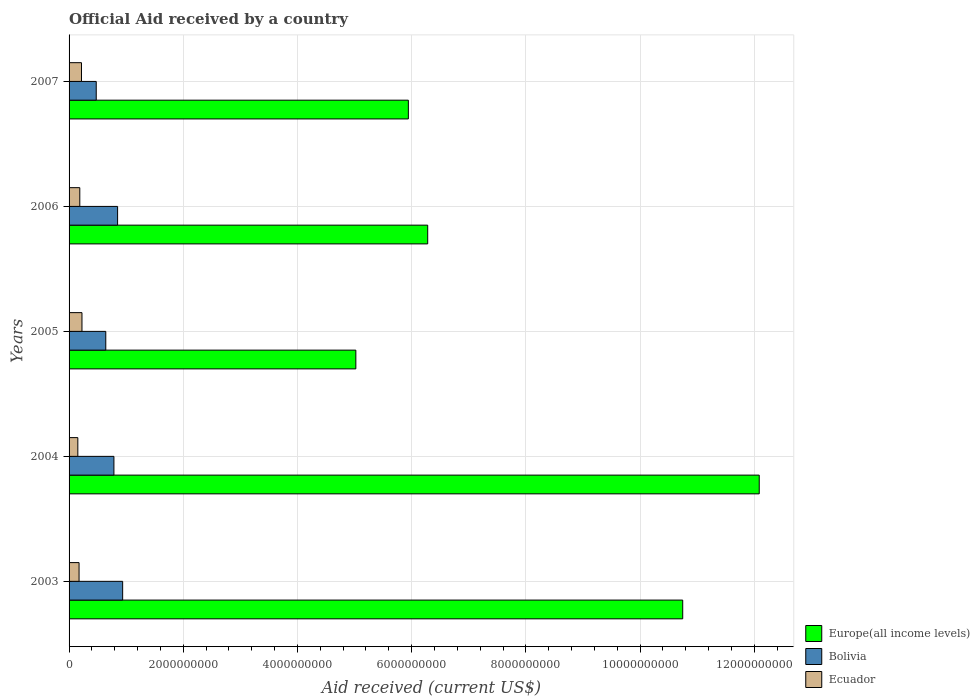How many different coloured bars are there?
Ensure brevity in your answer.  3. What is the net official aid received in Ecuador in 2004?
Offer a very short reply. 1.53e+08. Across all years, what is the maximum net official aid received in Ecuador?
Offer a terse response. 2.26e+08. Across all years, what is the minimum net official aid received in Ecuador?
Keep it short and to the point. 1.53e+08. In which year was the net official aid received in Ecuador maximum?
Your response must be concise. 2005. In which year was the net official aid received in Europe(all income levels) minimum?
Give a very brief answer. 2005. What is the total net official aid received in Bolivia in the graph?
Your answer should be very brief. 3.69e+09. What is the difference between the net official aid received in Europe(all income levels) in 2003 and that in 2004?
Offer a very short reply. -1.34e+09. What is the difference between the net official aid received in Europe(all income levels) in 2004 and the net official aid received in Ecuador in 2003?
Your response must be concise. 1.19e+1. What is the average net official aid received in Bolivia per year?
Your response must be concise. 7.39e+08. In the year 2007, what is the difference between the net official aid received in Europe(all income levels) and net official aid received in Ecuador?
Your response must be concise. 5.73e+09. What is the ratio of the net official aid received in Bolivia in 2003 to that in 2005?
Ensure brevity in your answer.  1.46. What is the difference between the highest and the second highest net official aid received in Europe(all income levels)?
Your response must be concise. 1.34e+09. What is the difference between the highest and the lowest net official aid received in Bolivia?
Your answer should be compact. 4.63e+08. What does the 1st bar from the bottom in 2005 represents?
Your answer should be compact. Europe(all income levels). How many bars are there?
Give a very brief answer. 15. How many years are there in the graph?
Make the answer very short. 5. What is the difference between two consecutive major ticks on the X-axis?
Give a very brief answer. 2.00e+09. Does the graph contain grids?
Provide a succinct answer. Yes. What is the title of the graph?
Your answer should be very brief. Official Aid received by a country. What is the label or title of the X-axis?
Keep it short and to the point. Aid received (current US$). What is the label or title of the Y-axis?
Provide a succinct answer. Years. What is the Aid received (current US$) of Europe(all income levels) in 2003?
Provide a succinct answer. 1.07e+1. What is the Aid received (current US$) of Bolivia in 2003?
Provide a succinct answer. 9.38e+08. What is the Aid received (current US$) in Ecuador in 2003?
Offer a terse response. 1.75e+08. What is the Aid received (current US$) of Europe(all income levels) in 2004?
Keep it short and to the point. 1.21e+1. What is the Aid received (current US$) of Bolivia in 2004?
Offer a terse response. 7.85e+08. What is the Aid received (current US$) in Ecuador in 2004?
Ensure brevity in your answer.  1.53e+08. What is the Aid received (current US$) in Europe(all income levels) in 2005?
Make the answer very short. 5.02e+09. What is the Aid received (current US$) of Bolivia in 2005?
Provide a short and direct response. 6.43e+08. What is the Aid received (current US$) of Ecuador in 2005?
Your answer should be compact. 2.26e+08. What is the Aid received (current US$) of Europe(all income levels) in 2006?
Your answer should be very brief. 6.28e+09. What is the Aid received (current US$) in Bolivia in 2006?
Offer a terse response. 8.50e+08. What is the Aid received (current US$) in Ecuador in 2006?
Give a very brief answer. 1.88e+08. What is the Aid received (current US$) in Europe(all income levels) in 2007?
Give a very brief answer. 5.94e+09. What is the Aid received (current US$) in Bolivia in 2007?
Give a very brief answer. 4.76e+08. What is the Aid received (current US$) of Ecuador in 2007?
Give a very brief answer. 2.17e+08. Across all years, what is the maximum Aid received (current US$) of Europe(all income levels)?
Provide a short and direct response. 1.21e+1. Across all years, what is the maximum Aid received (current US$) of Bolivia?
Your answer should be compact. 9.38e+08. Across all years, what is the maximum Aid received (current US$) in Ecuador?
Give a very brief answer. 2.26e+08. Across all years, what is the minimum Aid received (current US$) in Europe(all income levels)?
Offer a very short reply. 5.02e+09. Across all years, what is the minimum Aid received (current US$) in Bolivia?
Your answer should be compact. 4.76e+08. Across all years, what is the minimum Aid received (current US$) of Ecuador?
Your answer should be compact. 1.53e+08. What is the total Aid received (current US$) of Europe(all income levels) in the graph?
Offer a very short reply. 4.01e+1. What is the total Aid received (current US$) in Bolivia in the graph?
Provide a short and direct response. 3.69e+09. What is the total Aid received (current US$) in Ecuador in the graph?
Provide a succinct answer. 9.59e+08. What is the difference between the Aid received (current US$) in Europe(all income levels) in 2003 and that in 2004?
Offer a terse response. -1.34e+09. What is the difference between the Aid received (current US$) of Bolivia in 2003 and that in 2004?
Your response must be concise. 1.53e+08. What is the difference between the Aid received (current US$) of Ecuador in 2003 and that in 2004?
Provide a succinct answer. 2.16e+07. What is the difference between the Aid received (current US$) in Europe(all income levels) in 2003 and that in 2005?
Your answer should be compact. 5.72e+09. What is the difference between the Aid received (current US$) of Bolivia in 2003 and that in 2005?
Provide a short and direct response. 2.95e+08. What is the difference between the Aid received (current US$) in Ecuador in 2003 and that in 2005?
Offer a terse response. -5.09e+07. What is the difference between the Aid received (current US$) in Europe(all income levels) in 2003 and that in 2006?
Provide a succinct answer. 4.47e+09. What is the difference between the Aid received (current US$) of Bolivia in 2003 and that in 2006?
Ensure brevity in your answer.  8.84e+07. What is the difference between the Aid received (current US$) of Ecuador in 2003 and that in 2006?
Your response must be concise. -1.28e+07. What is the difference between the Aid received (current US$) of Europe(all income levels) in 2003 and that in 2007?
Offer a terse response. 4.81e+09. What is the difference between the Aid received (current US$) in Bolivia in 2003 and that in 2007?
Ensure brevity in your answer.  4.63e+08. What is the difference between the Aid received (current US$) in Ecuador in 2003 and that in 2007?
Ensure brevity in your answer.  -4.24e+07. What is the difference between the Aid received (current US$) in Europe(all income levels) in 2004 and that in 2005?
Offer a very short reply. 7.07e+09. What is the difference between the Aid received (current US$) of Bolivia in 2004 and that in 2005?
Your answer should be very brief. 1.42e+08. What is the difference between the Aid received (current US$) of Ecuador in 2004 and that in 2005?
Ensure brevity in your answer.  -7.25e+07. What is the difference between the Aid received (current US$) of Europe(all income levels) in 2004 and that in 2006?
Give a very brief answer. 5.81e+09. What is the difference between the Aid received (current US$) in Bolivia in 2004 and that in 2006?
Ensure brevity in your answer.  -6.45e+07. What is the difference between the Aid received (current US$) of Ecuador in 2004 and that in 2006?
Your response must be concise. -3.45e+07. What is the difference between the Aid received (current US$) of Europe(all income levels) in 2004 and that in 2007?
Keep it short and to the point. 6.15e+09. What is the difference between the Aid received (current US$) in Bolivia in 2004 and that in 2007?
Offer a very short reply. 3.10e+08. What is the difference between the Aid received (current US$) in Ecuador in 2004 and that in 2007?
Keep it short and to the point. -6.40e+07. What is the difference between the Aid received (current US$) in Europe(all income levels) in 2005 and that in 2006?
Your response must be concise. -1.26e+09. What is the difference between the Aid received (current US$) in Bolivia in 2005 and that in 2006?
Your answer should be compact. -2.07e+08. What is the difference between the Aid received (current US$) of Ecuador in 2005 and that in 2006?
Provide a succinct answer. 3.80e+07. What is the difference between the Aid received (current US$) of Europe(all income levels) in 2005 and that in 2007?
Ensure brevity in your answer.  -9.20e+08. What is the difference between the Aid received (current US$) in Bolivia in 2005 and that in 2007?
Provide a succinct answer. 1.67e+08. What is the difference between the Aid received (current US$) of Ecuador in 2005 and that in 2007?
Keep it short and to the point. 8.52e+06. What is the difference between the Aid received (current US$) of Europe(all income levels) in 2006 and that in 2007?
Your response must be concise. 3.39e+08. What is the difference between the Aid received (current US$) of Bolivia in 2006 and that in 2007?
Offer a very short reply. 3.74e+08. What is the difference between the Aid received (current US$) of Ecuador in 2006 and that in 2007?
Make the answer very short. -2.95e+07. What is the difference between the Aid received (current US$) in Europe(all income levels) in 2003 and the Aid received (current US$) in Bolivia in 2004?
Offer a very short reply. 9.96e+09. What is the difference between the Aid received (current US$) in Europe(all income levels) in 2003 and the Aid received (current US$) in Ecuador in 2004?
Ensure brevity in your answer.  1.06e+1. What is the difference between the Aid received (current US$) of Bolivia in 2003 and the Aid received (current US$) of Ecuador in 2004?
Provide a short and direct response. 7.85e+08. What is the difference between the Aid received (current US$) of Europe(all income levels) in 2003 and the Aid received (current US$) of Bolivia in 2005?
Your answer should be compact. 1.01e+1. What is the difference between the Aid received (current US$) of Europe(all income levels) in 2003 and the Aid received (current US$) of Ecuador in 2005?
Make the answer very short. 1.05e+1. What is the difference between the Aid received (current US$) in Bolivia in 2003 and the Aid received (current US$) in Ecuador in 2005?
Give a very brief answer. 7.13e+08. What is the difference between the Aid received (current US$) in Europe(all income levels) in 2003 and the Aid received (current US$) in Bolivia in 2006?
Make the answer very short. 9.90e+09. What is the difference between the Aid received (current US$) of Europe(all income levels) in 2003 and the Aid received (current US$) of Ecuador in 2006?
Keep it short and to the point. 1.06e+1. What is the difference between the Aid received (current US$) in Bolivia in 2003 and the Aid received (current US$) in Ecuador in 2006?
Provide a succinct answer. 7.51e+08. What is the difference between the Aid received (current US$) in Europe(all income levels) in 2003 and the Aid received (current US$) in Bolivia in 2007?
Provide a short and direct response. 1.03e+1. What is the difference between the Aid received (current US$) of Europe(all income levels) in 2003 and the Aid received (current US$) of Ecuador in 2007?
Your answer should be very brief. 1.05e+1. What is the difference between the Aid received (current US$) in Bolivia in 2003 and the Aid received (current US$) in Ecuador in 2007?
Your response must be concise. 7.21e+08. What is the difference between the Aid received (current US$) in Europe(all income levels) in 2004 and the Aid received (current US$) in Bolivia in 2005?
Offer a terse response. 1.14e+1. What is the difference between the Aid received (current US$) in Europe(all income levels) in 2004 and the Aid received (current US$) in Ecuador in 2005?
Offer a terse response. 1.19e+1. What is the difference between the Aid received (current US$) of Bolivia in 2004 and the Aid received (current US$) of Ecuador in 2005?
Ensure brevity in your answer.  5.60e+08. What is the difference between the Aid received (current US$) of Europe(all income levels) in 2004 and the Aid received (current US$) of Bolivia in 2006?
Offer a very short reply. 1.12e+1. What is the difference between the Aid received (current US$) of Europe(all income levels) in 2004 and the Aid received (current US$) of Ecuador in 2006?
Give a very brief answer. 1.19e+1. What is the difference between the Aid received (current US$) in Bolivia in 2004 and the Aid received (current US$) in Ecuador in 2006?
Provide a succinct answer. 5.98e+08. What is the difference between the Aid received (current US$) in Europe(all income levels) in 2004 and the Aid received (current US$) in Bolivia in 2007?
Offer a very short reply. 1.16e+1. What is the difference between the Aid received (current US$) in Europe(all income levels) in 2004 and the Aid received (current US$) in Ecuador in 2007?
Keep it short and to the point. 1.19e+1. What is the difference between the Aid received (current US$) in Bolivia in 2004 and the Aid received (current US$) in Ecuador in 2007?
Your response must be concise. 5.68e+08. What is the difference between the Aid received (current US$) in Europe(all income levels) in 2005 and the Aid received (current US$) in Bolivia in 2006?
Your answer should be compact. 4.17e+09. What is the difference between the Aid received (current US$) in Europe(all income levels) in 2005 and the Aid received (current US$) in Ecuador in 2006?
Offer a very short reply. 4.83e+09. What is the difference between the Aid received (current US$) in Bolivia in 2005 and the Aid received (current US$) in Ecuador in 2006?
Your response must be concise. 4.55e+08. What is the difference between the Aid received (current US$) in Europe(all income levels) in 2005 and the Aid received (current US$) in Bolivia in 2007?
Ensure brevity in your answer.  4.55e+09. What is the difference between the Aid received (current US$) in Europe(all income levels) in 2005 and the Aid received (current US$) in Ecuador in 2007?
Offer a very short reply. 4.81e+09. What is the difference between the Aid received (current US$) of Bolivia in 2005 and the Aid received (current US$) of Ecuador in 2007?
Offer a very short reply. 4.26e+08. What is the difference between the Aid received (current US$) in Europe(all income levels) in 2006 and the Aid received (current US$) in Bolivia in 2007?
Offer a terse response. 5.81e+09. What is the difference between the Aid received (current US$) of Europe(all income levels) in 2006 and the Aid received (current US$) of Ecuador in 2007?
Your answer should be compact. 6.06e+09. What is the difference between the Aid received (current US$) of Bolivia in 2006 and the Aid received (current US$) of Ecuador in 2007?
Ensure brevity in your answer.  6.33e+08. What is the average Aid received (current US$) of Europe(all income levels) per year?
Provide a short and direct response. 8.02e+09. What is the average Aid received (current US$) in Bolivia per year?
Provide a succinct answer. 7.39e+08. What is the average Aid received (current US$) of Ecuador per year?
Offer a terse response. 1.92e+08. In the year 2003, what is the difference between the Aid received (current US$) in Europe(all income levels) and Aid received (current US$) in Bolivia?
Make the answer very short. 9.81e+09. In the year 2003, what is the difference between the Aid received (current US$) of Europe(all income levels) and Aid received (current US$) of Ecuador?
Keep it short and to the point. 1.06e+1. In the year 2003, what is the difference between the Aid received (current US$) in Bolivia and Aid received (current US$) in Ecuador?
Keep it short and to the point. 7.63e+08. In the year 2004, what is the difference between the Aid received (current US$) in Europe(all income levels) and Aid received (current US$) in Bolivia?
Your answer should be compact. 1.13e+1. In the year 2004, what is the difference between the Aid received (current US$) of Europe(all income levels) and Aid received (current US$) of Ecuador?
Offer a very short reply. 1.19e+1. In the year 2004, what is the difference between the Aid received (current US$) of Bolivia and Aid received (current US$) of Ecuador?
Your answer should be compact. 6.32e+08. In the year 2005, what is the difference between the Aid received (current US$) in Europe(all income levels) and Aid received (current US$) in Bolivia?
Ensure brevity in your answer.  4.38e+09. In the year 2005, what is the difference between the Aid received (current US$) in Europe(all income levels) and Aid received (current US$) in Ecuador?
Provide a succinct answer. 4.80e+09. In the year 2005, what is the difference between the Aid received (current US$) of Bolivia and Aid received (current US$) of Ecuador?
Keep it short and to the point. 4.17e+08. In the year 2006, what is the difference between the Aid received (current US$) in Europe(all income levels) and Aid received (current US$) in Bolivia?
Make the answer very short. 5.43e+09. In the year 2006, what is the difference between the Aid received (current US$) of Europe(all income levels) and Aid received (current US$) of Ecuador?
Make the answer very short. 6.09e+09. In the year 2006, what is the difference between the Aid received (current US$) in Bolivia and Aid received (current US$) in Ecuador?
Give a very brief answer. 6.62e+08. In the year 2007, what is the difference between the Aid received (current US$) of Europe(all income levels) and Aid received (current US$) of Bolivia?
Keep it short and to the point. 5.47e+09. In the year 2007, what is the difference between the Aid received (current US$) of Europe(all income levels) and Aid received (current US$) of Ecuador?
Make the answer very short. 5.73e+09. In the year 2007, what is the difference between the Aid received (current US$) of Bolivia and Aid received (current US$) of Ecuador?
Provide a succinct answer. 2.59e+08. What is the ratio of the Aid received (current US$) of Europe(all income levels) in 2003 to that in 2004?
Offer a terse response. 0.89. What is the ratio of the Aid received (current US$) of Bolivia in 2003 to that in 2004?
Ensure brevity in your answer.  1.19. What is the ratio of the Aid received (current US$) of Ecuador in 2003 to that in 2004?
Your response must be concise. 1.14. What is the ratio of the Aid received (current US$) of Europe(all income levels) in 2003 to that in 2005?
Your response must be concise. 2.14. What is the ratio of the Aid received (current US$) of Bolivia in 2003 to that in 2005?
Provide a succinct answer. 1.46. What is the ratio of the Aid received (current US$) in Ecuador in 2003 to that in 2005?
Keep it short and to the point. 0.77. What is the ratio of the Aid received (current US$) of Europe(all income levels) in 2003 to that in 2006?
Give a very brief answer. 1.71. What is the ratio of the Aid received (current US$) in Bolivia in 2003 to that in 2006?
Your answer should be very brief. 1.1. What is the ratio of the Aid received (current US$) of Ecuador in 2003 to that in 2006?
Provide a short and direct response. 0.93. What is the ratio of the Aid received (current US$) in Europe(all income levels) in 2003 to that in 2007?
Offer a very short reply. 1.81. What is the ratio of the Aid received (current US$) in Bolivia in 2003 to that in 2007?
Make the answer very short. 1.97. What is the ratio of the Aid received (current US$) in Ecuador in 2003 to that in 2007?
Make the answer very short. 0.81. What is the ratio of the Aid received (current US$) in Europe(all income levels) in 2004 to that in 2005?
Your answer should be compact. 2.41. What is the ratio of the Aid received (current US$) in Bolivia in 2004 to that in 2005?
Your response must be concise. 1.22. What is the ratio of the Aid received (current US$) of Ecuador in 2004 to that in 2005?
Your response must be concise. 0.68. What is the ratio of the Aid received (current US$) in Europe(all income levels) in 2004 to that in 2006?
Ensure brevity in your answer.  1.92. What is the ratio of the Aid received (current US$) of Bolivia in 2004 to that in 2006?
Your answer should be compact. 0.92. What is the ratio of the Aid received (current US$) of Ecuador in 2004 to that in 2006?
Make the answer very short. 0.82. What is the ratio of the Aid received (current US$) of Europe(all income levels) in 2004 to that in 2007?
Keep it short and to the point. 2.03. What is the ratio of the Aid received (current US$) of Bolivia in 2004 to that in 2007?
Provide a short and direct response. 1.65. What is the ratio of the Aid received (current US$) of Ecuador in 2004 to that in 2007?
Ensure brevity in your answer.  0.71. What is the ratio of the Aid received (current US$) in Europe(all income levels) in 2005 to that in 2006?
Your response must be concise. 0.8. What is the ratio of the Aid received (current US$) in Bolivia in 2005 to that in 2006?
Make the answer very short. 0.76. What is the ratio of the Aid received (current US$) of Ecuador in 2005 to that in 2006?
Provide a short and direct response. 1.2. What is the ratio of the Aid received (current US$) of Europe(all income levels) in 2005 to that in 2007?
Provide a succinct answer. 0.85. What is the ratio of the Aid received (current US$) in Bolivia in 2005 to that in 2007?
Ensure brevity in your answer.  1.35. What is the ratio of the Aid received (current US$) of Ecuador in 2005 to that in 2007?
Make the answer very short. 1.04. What is the ratio of the Aid received (current US$) of Europe(all income levels) in 2006 to that in 2007?
Your answer should be very brief. 1.06. What is the ratio of the Aid received (current US$) of Bolivia in 2006 to that in 2007?
Ensure brevity in your answer.  1.79. What is the ratio of the Aid received (current US$) of Ecuador in 2006 to that in 2007?
Your answer should be compact. 0.86. What is the difference between the highest and the second highest Aid received (current US$) in Europe(all income levels)?
Give a very brief answer. 1.34e+09. What is the difference between the highest and the second highest Aid received (current US$) in Bolivia?
Give a very brief answer. 8.84e+07. What is the difference between the highest and the second highest Aid received (current US$) of Ecuador?
Provide a short and direct response. 8.52e+06. What is the difference between the highest and the lowest Aid received (current US$) in Europe(all income levels)?
Your answer should be very brief. 7.07e+09. What is the difference between the highest and the lowest Aid received (current US$) in Bolivia?
Your answer should be very brief. 4.63e+08. What is the difference between the highest and the lowest Aid received (current US$) of Ecuador?
Your response must be concise. 7.25e+07. 